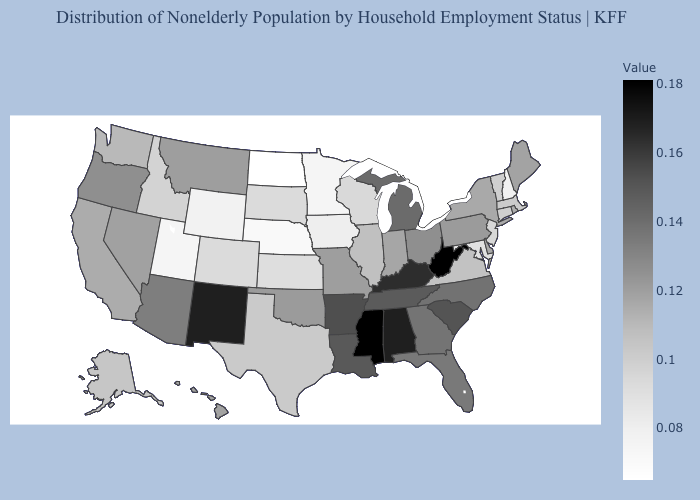Among the states that border Louisiana , does Mississippi have the highest value?
Answer briefly. Yes. Which states have the lowest value in the USA?
Give a very brief answer. North Dakota. Among the states that border Minnesota , which have the lowest value?
Concise answer only. North Dakota. Among the states that border Arkansas , which have the highest value?
Give a very brief answer. Mississippi. 